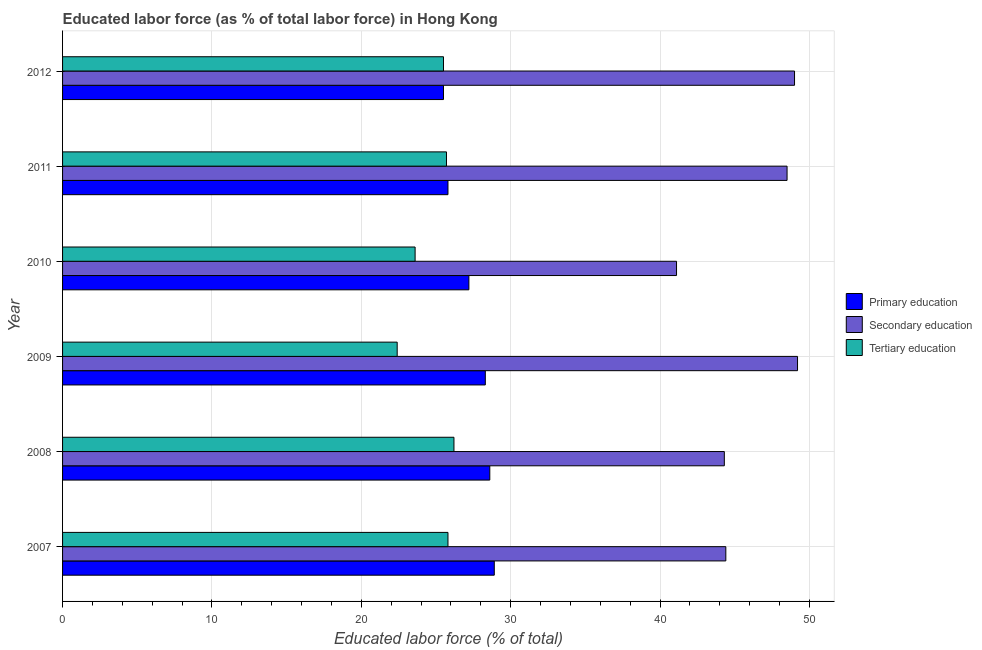How many groups of bars are there?
Your answer should be compact. 6. Are the number of bars per tick equal to the number of legend labels?
Offer a terse response. Yes. What is the label of the 2nd group of bars from the top?
Provide a short and direct response. 2011. In how many cases, is the number of bars for a given year not equal to the number of legend labels?
Give a very brief answer. 0. What is the percentage of labor force who received primary education in 2012?
Your answer should be compact. 25.5. Across all years, what is the maximum percentage of labor force who received primary education?
Your response must be concise. 28.9. Across all years, what is the minimum percentage of labor force who received secondary education?
Provide a short and direct response. 41.1. In which year was the percentage of labor force who received tertiary education minimum?
Your answer should be very brief. 2009. What is the total percentage of labor force who received primary education in the graph?
Give a very brief answer. 164.3. What is the difference between the percentage of labor force who received secondary education in 2007 and that in 2010?
Make the answer very short. 3.3. What is the difference between the percentage of labor force who received primary education in 2007 and the percentage of labor force who received secondary education in 2012?
Make the answer very short. -20.1. What is the average percentage of labor force who received primary education per year?
Provide a succinct answer. 27.38. In the year 2012, what is the difference between the percentage of labor force who received tertiary education and percentage of labor force who received secondary education?
Make the answer very short. -23.5. In how many years, is the percentage of labor force who received secondary education greater than 28 %?
Give a very brief answer. 6. What is the ratio of the percentage of labor force who received secondary education in 2007 to that in 2012?
Provide a short and direct response. 0.91. What is the difference between the highest and the lowest percentage of labor force who received tertiary education?
Keep it short and to the point. 3.8. In how many years, is the percentage of labor force who received secondary education greater than the average percentage of labor force who received secondary education taken over all years?
Keep it short and to the point. 3. What does the 3rd bar from the top in 2008 represents?
Make the answer very short. Primary education. What does the 2nd bar from the bottom in 2007 represents?
Provide a succinct answer. Secondary education. How many bars are there?
Ensure brevity in your answer.  18. How many years are there in the graph?
Provide a succinct answer. 6. How many legend labels are there?
Your answer should be very brief. 3. What is the title of the graph?
Offer a very short reply. Educated labor force (as % of total labor force) in Hong Kong. Does "Taxes on goods and services" appear as one of the legend labels in the graph?
Give a very brief answer. No. What is the label or title of the X-axis?
Give a very brief answer. Educated labor force (% of total). What is the Educated labor force (% of total) in Primary education in 2007?
Offer a very short reply. 28.9. What is the Educated labor force (% of total) of Secondary education in 2007?
Your answer should be very brief. 44.4. What is the Educated labor force (% of total) in Tertiary education in 2007?
Make the answer very short. 25.8. What is the Educated labor force (% of total) of Primary education in 2008?
Keep it short and to the point. 28.6. What is the Educated labor force (% of total) of Secondary education in 2008?
Make the answer very short. 44.3. What is the Educated labor force (% of total) in Tertiary education in 2008?
Provide a short and direct response. 26.2. What is the Educated labor force (% of total) of Primary education in 2009?
Your response must be concise. 28.3. What is the Educated labor force (% of total) of Secondary education in 2009?
Give a very brief answer. 49.2. What is the Educated labor force (% of total) in Tertiary education in 2009?
Offer a very short reply. 22.4. What is the Educated labor force (% of total) in Primary education in 2010?
Your answer should be very brief. 27.2. What is the Educated labor force (% of total) of Secondary education in 2010?
Your response must be concise. 41.1. What is the Educated labor force (% of total) of Tertiary education in 2010?
Ensure brevity in your answer.  23.6. What is the Educated labor force (% of total) in Primary education in 2011?
Make the answer very short. 25.8. What is the Educated labor force (% of total) of Secondary education in 2011?
Offer a very short reply. 48.5. What is the Educated labor force (% of total) of Tertiary education in 2011?
Keep it short and to the point. 25.7. Across all years, what is the maximum Educated labor force (% of total) in Primary education?
Your answer should be very brief. 28.9. Across all years, what is the maximum Educated labor force (% of total) in Secondary education?
Keep it short and to the point. 49.2. Across all years, what is the maximum Educated labor force (% of total) in Tertiary education?
Offer a terse response. 26.2. Across all years, what is the minimum Educated labor force (% of total) in Primary education?
Your response must be concise. 25.5. Across all years, what is the minimum Educated labor force (% of total) in Secondary education?
Offer a very short reply. 41.1. Across all years, what is the minimum Educated labor force (% of total) in Tertiary education?
Offer a terse response. 22.4. What is the total Educated labor force (% of total) of Primary education in the graph?
Make the answer very short. 164.3. What is the total Educated labor force (% of total) of Secondary education in the graph?
Provide a short and direct response. 276.5. What is the total Educated labor force (% of total) in Tertiary education in the graph?
Keep it short and to the point. 149.2. What is the difference between the Educated labor force (% of total) of Secondary education in 2007 and that in 2008?
Make the answer very short. 0.1. What is the difference between the Educated labor force (% of total) of Tertiary education in 2007 and that in 2008?
Provide a short and direct response. -0.4. What is the difference between the Educated labor force (% of total) in Primary education in 2007 and that in 2009?
Your response must be concise. 0.6. What is the difference between the Educated labor force (% of total) in Primary education in 2007 and that in 2010?
Your response must be concise. 1.7. What is the difference between the Educated labor force (% of total) of Secondary education in 2007 and that in 2010?
Provide a short and direct response. 3.3. What is the difference between the Educated labor force (% of total) of Primary education in 2007 and that in 2011?
Your answer should be compact. 3.1. What is the difference between the Educated labor force (% of total) in Secondary education in 2007 and that in 2011?
Keep it short and to the point. -4.1. What is the difference between the Educated labor force (% of total) of Primary education in 2007 and that in 2012?
Give a very brief answer. 3.4. What is the difference between the Educated labor force (% of total) of Secondary education in 2007 and that in 2012?
Keep it short and to the point. -4.6. What is the difference between the Educated labor force (% of total) in Tertiary education in 2007 and that in 2012?
Keep it short and to the point. 0.3. What is the difference between the Educated labor force (% of total) in Primary education in 2008 and that in 2009?
Give a very brief answer. 0.3. What is the difference between the Educated labor force (% of total) in Tertiary education in 2008 and that in 2009?
Your answer should be compact. 3.8. What is the difference between the Educated labor force (% of total) of Primary education in 2008 and that in 2010?
Offer a very short reply. 1.4. What is the difference between the Educated labor force (% of total) in Tertiary education in 2008 and that in 2010?
Provide a short and direct response. 2.6. What is the difference between the Educated labor force (% of total) of Tertiary education in 2008 and that in 2011?
Make the answer very short. 0.5. What is the difference between the Educated labor force (% of total) of Primary education in 2009 and that in 2010?
Your response must be concise. 1.1. What is the difference between the Educated labor force (% of total) in Tertiary education in 2009 and that in 2010?
Your answer should be compact. -1.2. What is the difference between the Educated labor force (% of total) in Primary education in 2009 and that in 2011?
Offer a very short reply. 2.5. What is the difference between the Educated labor force (% of total) of Secondary education in 2009 and that in 2012?
Give a very brief answer. 0.2. What is the difference between the Educated labor force (% of total) of Primary education in 2010 and that in 2011?
Your answer should be compact. 1.4. What is the difference between the Educated labor force (% of total) of Tertiary education in 2010 and that in 2011?
Make the answer very short. -2.1. What is the difference between the Educated labor force (% of total) in Primary education in 2010 and that in 2012?
Provide a succinct answer. 1.7. What is the difference between the Educated labor force (% of total) of Secondary education in 2010 and that in 2012?
Provide a succinct answer. -7.9. What is the difference between the Educated labor force (% of total) in Tertiary education in 2010 and that in 2012?
Keep it short and to the point. -1.9. What is the difference between the Educated labor force (% of total) in Tertiary education in 2011 and that in 2012?
Your answer should be very brief. 0.2. What is the difference between the Educated labor force (% of total) in Primary education in 2007 and the Educated labor force (% of total) in Secondary education in 2008?
Keep it short and to the point. -15.4. What is the difference between the Educated labor force (% of total) in Primary education in 2007 and the Educated labor force (% of total) in Secondary education in 2009?
Ensure brevity in your answer.  -20.3. What is the difference between the Educated labor force (% of total) of Secondary education in 2007 and the Educated labor force (% of total) of Tertiary education in 2010?
Keep it short and to the point. 20.8. What is the difference between the Educated labor force (% of total) in Primary education in 2007 and the Educated labor force (% of total) in Secondary education in 2011?
Your answer should be compact. -19.6. What is the difference between the Educated labor force (% of total) of Primary education in 2007 and the Educated labor force (% of total) of Secondary education in 2012?
Make the answer very short. -20.1. What is the difference between the Educated labor force (% of total) of Primary education in 2008 and the Educated labor force (% of total) of Secondary education in 2009?
Give a very brief answer. -20.6. What is the difference between the Educated labor force (% of total) in Primary education in 2008 and the Educated labor force (% of total) in Tertiary education in 2009?
Ensure brevity in your answer.  6.2. What is the difference between the Educated labor force (% of total) of Secondary education in 2008 and the Educated labor force (% of total) of Tertiary education in 2009?
Your answer should be compact. 21.9. What is the difference between the Educated labor force (% of total) in Primary education in 2008 and the Educated labor force (% of total) in Secondary education in 2010?
Offer a very short reply. -12.5. What is the difference between the Educated labor force (% of total) of Primary education in 2008 and the Educated labor force (% of total) of Tertiary education in 2010?
Your response must be concise. 5. What is the difference between the Educated labor force (% of total) of Secondary education in 2008 and the Educated labor force (% of total) of Tertiary education in 2010?
Provide a succinct answer. 20.7. What is the difference between the Educated labor force (% of total) in Primary education in 2008 and the Educated labor force (% of total) in Secondary education in 2011?
Keep it short and to the point. -19.9. What is the difference between the Educated labor force (% of total) in Secondary education in 2008 and the Educated labor force (% of total) in Tertiary education in 2011?
Ensure brevity in your answer.  18.6. What is the difference between the Educated labor force (% of total) in Primary education in 2008 and the Educated labor force (% of total) in Secondary education in 2012?
Your answer should be very brief. -20.4. What is the difference between the Educated labor force (% of total) in Primary education in 2008 and the Educated labor force (% of total) in Tertiary education in 2012?
Your answer should be compact. 3.1. What is the difference between the Educated labor force (% of total) of Primary education in 2009 and the Educated labor force (% of total) of Tertiary education in 2010?
Keep it short and to the point. 4.7. What is the difference between the Educated labor force (% of total) of Secondary education in 2009 and the Educated labor force (% of total) of Tertiary education in 2010?
Offer a very short reply. 25.6. What is the difference between the Educated labor force (% of total) of Primary education in 2009 and the Educated labor force (% of total) of Secondary education in 2011?
Your answer should be very brief. -20.2. What is the difference between the Educated labor force (% of total) of Primary education in 2009 and the Educated labor force (% of total) of Secondary education in 2012?
Offer a very short reply. -20.7. What is the difference between the Educated labor force (% of total) in Secondary education in 2009 and the Educated labor force (% of total) in Tertiary education in 2012?
Offer a very short reply. 23.7. What is the difference between the Educated labor force (% of total) of Primary education in 2010 and the Educated labor force (% of total) of Secondary education in 2011?
Offer a very short reply. -21.3. What is the difference between the Educated labor force (% of total) in Primary education in 2010 and the Educated labor force (% of total) in Tertiary education in 2011?
Ensure brevity in your answer.  1.5. What is the difference between the Educated labor force (% of total) in Primary education in 2010 and the Educated labor force (% of total) in Secondary education in 2012?
Provide a succinct answer. -21.8. What is the difference between the Educated labor force (% of total) of Primary education in 2011 and the Educated labor force (% of total) of Secondary education in 2012?
Make the answer very short. -23.2. What is the difference between the Educated labor force (% of total) in Primary education in 2011 and the Educated labor force (% of total) in Tertiary education in 2012?
Keep it short and to the point. 0.3. What is the average Educated labor force (% of total) in Primary education per year?
Make the answer very short. 27.38. What is the average Educated labor force (% of total) of Secondary education per year?
Make the answer very short. 46.08. What is the average Educated labor force (% of total) of Tertiary education per year?
Your answer should be very brief. 24.87. In the year 2007, what is the difference between the Educated labor force (% of total) of Primary education and Educated labor force (% of total) of Secondary education?
Offer a very short reply. -15.5. In the year 2007, what is the difference between the Educated labor force (% of total) in Primary education and Educated labor force (% of total) in Tertiary education?
Offer a very short reply. 3.1. In the year 2008, what is the difference between the Educated labor force (% of total) of Primary education and Educated labor force (% of total) of Secondary education?
Provide a succinct answer. -15.7. In the year 2009, what is the difference between the Educated labor force (% of total) in Primary education and Educated labor force (% of total) in Secondary education?
Your answer should be compact. -20.9. In the year 2009, what is the difference between the Educated labor force (% of total) in Secondary education and Educated labor force (% of total) in Tertiary education?
Give a very brief answer. 26.8. In the year 2010, what is the difference between the Educated labor force (% of total) of Primary education and Educated labor force (% of total) of Secondary education?
Offer a terse response. -13.9. In the year 2010, what is the difference between the Educated labor force (% of total) of Primary education and Educated labor force (% of total) of Tertiary education?
Give a very brief answer. 3.6. In the year 2011, what is the difference between the Educated labor force (% of total) in Primary education and Educated labor force (% of total) in Secondary education?
Offer a terse response. -22.7. In the year 2011, what is the difference between the Educated labor force (% of total) in Secondary education and Educated labor force (% of total) in Tertiary education?
Your answer should be compact. 22.8. In the year 2012, what is the difference between the Educated labor force (% of total) of Primary education and Educated labor force (% of total) of Secondary education?
Your answer should be compact. -23.5. In the year 2012, what is the difference between the Educated labor force (% of total) in Secondary education and Educated labor force (% of total) in Tertiary education?
Ensure brevity in your answer.  23.5. What is the ratio of the Educated labor force (% of total) in Primary education in 2007 to that in 2008?
Ensure brevity in your answer.  1.01. What is the ratio of the Educated labor force (% of total) in Tertiary education in 2007 to that in 2008?
Offer a very short reply. 0.98. What is the ratio of the Educated labor force (% of total) in Primary education in 2007 to that in 2009?
Offer a very short reply. 1.02. What is the ratio of the Educated labor force (% of total) in Secondary education in 2007 to that in 2009?
Ensure brevity in your answer.  0.9. What is the ratio of the Educated labor force (% of total) in Tertiary education in 2007 to that in 2009?
Provide a succinct answer. 1.15. What is the ratio of the Educated labor force (% of total) of Primary education in 2007 to that in 2010?
Offer a very short reply. 1.06. What is the ratio of the Educated labor force (% of total) of Secondary education in 2007 to that in 2010?
Ensure brevity in your answer.  1.08. What is the ratio of the Educated labor force (% of total) in Tertiary education in 2007 to that in 2010?
Your answer should be very brief. 1.09. What is the ratio of the Educated labor force (% of total) of Primary education in 2007 to that in 2011?
Provide a short and direct response. 1.12. What is the ratio of the Educated labor force (% of total) of Secondary education in 2007 to that in 2011?
Your response must be concise. 0.92. What is the ratio of the Educated labor force (% of total) of Tertiary education in 2007 to that in 2011?
Your answer should be very brief. 1. What is the ratio of the Educated labor force (% of total) in Primary education in 2007 to that in 2012?
Give a very brief answer. 1.13. What is the ratio of the Educated labor force (% of total) of Secondary education in 2007 to that in 2012?
Provide a short and direct response. 0.91. What is the ratio of the Educated labor force (% of total) of Tertiary education in 2007 to that in 2012?
Provide a succinct answer. 1.01. What is the ratio of the Educated labor force (% of total) of Primary education in 2008 to that in 2009?
Provide a short and direct response. 1.01. What is the ratio of the Educated labor force (% of total) in Secondary education in 2008 to that in 2009?
Your answer should be very brief. 0.9. What is the ratio of the Educated labor force (% of total) of Tertiary education in 2008 to that in 2009?
Give a very brief answer. 1.17. What is the ratio of the Educated labor force (% of total) in Primary education in 2008 to that in 2010?
Your response must be concise. 1.05. What is the ratio of the Educated labor force (% of total) of Secondary education in 2008 to that in 2010?
Ensure brevity in your answer.  1.08. What is the ratio of the Educated labor force (% of total) of Tertiary education in 2008 to that in 2010?
Give a very brief answer. 1.11. What is the ratio of the Educated labor force (% of total) of Primary education in 2008 to that in 2011?
Your answer should be very brief. 1.11. What is the ratio of the Educated labor force (% of total) in Secondary education in 2008 to that in 2011?
Your answer should be compact. 0.91. What is the ratio of the Educated labor force (% of total) in Tertiary education in 2008 to that in 2011?
Your response must be concise. 1.02. What is the ratio of the Educated labor force (% of total) of Primary education in 2008 to that in 2012?
Your answer should be compact. 1.12. What is the ratio of the Educated labor force (% of total) in Secondary education in 2008 to that in 2012?
Make the answer very short. 0.9. What is the ratio of the Educated labor force (% of total) in Tertiary education in 2008 to that in 2012?
Keep it short and to the point. 1.03. What is the ratio of the Educated labor force (% of total) in Primary education in 2009 to that in 2010?
Your response must be concise. 1.04. What is the ratio of the Educated labor force (% of total) of Secondary education in 2009 to that in 2010?
Your answer should be very brief. 1.2. What is the ratio of the Educated labor force (% of total) in Tertiary education in 2009 to that in 2010?
Your answer should be compact. 0.95. What is the ratio of the Educated labor force (% of total) in Primary education in 2009 to that in 2011?
Ensure brevity in your answer.  1.1. What is the ratio of the Educated labor force (% of total) in Secondary education in 2009 to that in 2011?
Offer a very short reply. 1.01. What is the ratio of the Educated labor force (% of total) in Tertiary education in 2009 to that in 2011?
Your response must be concise. 0.87. What is the ratio of the Educated labor force (% of total) of Primary education in 2009 to that in 2012?
Keep it short and to the point. 1.11. What is the ratio of the Educated labor force (% of total) of Tertiary education in 2009 to that in 2012?
Provide a short and direct response. 0.88. What is the ratio of the Educated labor force (% of total) of Primary education in 2010 to that in 2011?
Your response must be concise. 1.05. What is the ratio of the Educated labor force (% of total) in Secondary education in 2010 to that in 2011?
Offer a terse response. 0.85. What is the ratio of the Educated labor force (% of total) of Tertiary education in 2010 to that in 2011?
Your answer should be compact. 0.92. What is the ratio of the Educated labor force (% of total) in Primary education in 2010 to that in 2012?
Offer a terse response. 1.07. What is the ratio of the Educated labor force (% of total) in Secondary education in 2010 to that in 2012?
Provide a succinct answer. 0.84. What is the ratio of the Educated labor force (% of total) in Tertiary education in 2010 to that in 2012?
Your answer should be very brief. 0.93. What is the ratio of the Educated labor force (% of total) in Primary education in 2011 to that in 2012?
Give a very brief answer. 1.01. What is the ratio of the Educated labor force (% of total) of Secondary education in 2011 to that in 2012?
Keep it short and to the point. 0.99. What is the ratio of the Educated labor force (% of total) in Tertiary education in 2011 to that in 2012?
Provide a succinct answer. 1.01. What is the difference between the highest and the second highest Educated labor force (% of total) of Primary education?
Ensure brevity in your answer.  0.3. What is the difference between the highest and the second highest Educated labor force (% of total) in Secondary education?
Offer a terse response. 0.2. What is the difference between the highest and the second highest Educated labor force (% of total) of Tertiary education?
Your answer should be compact. 0.4. What is the difference between the highest and the lowest Educated labor force (% of total) in Tertiary education?
Ensure brevity in your answer.  3.8. 